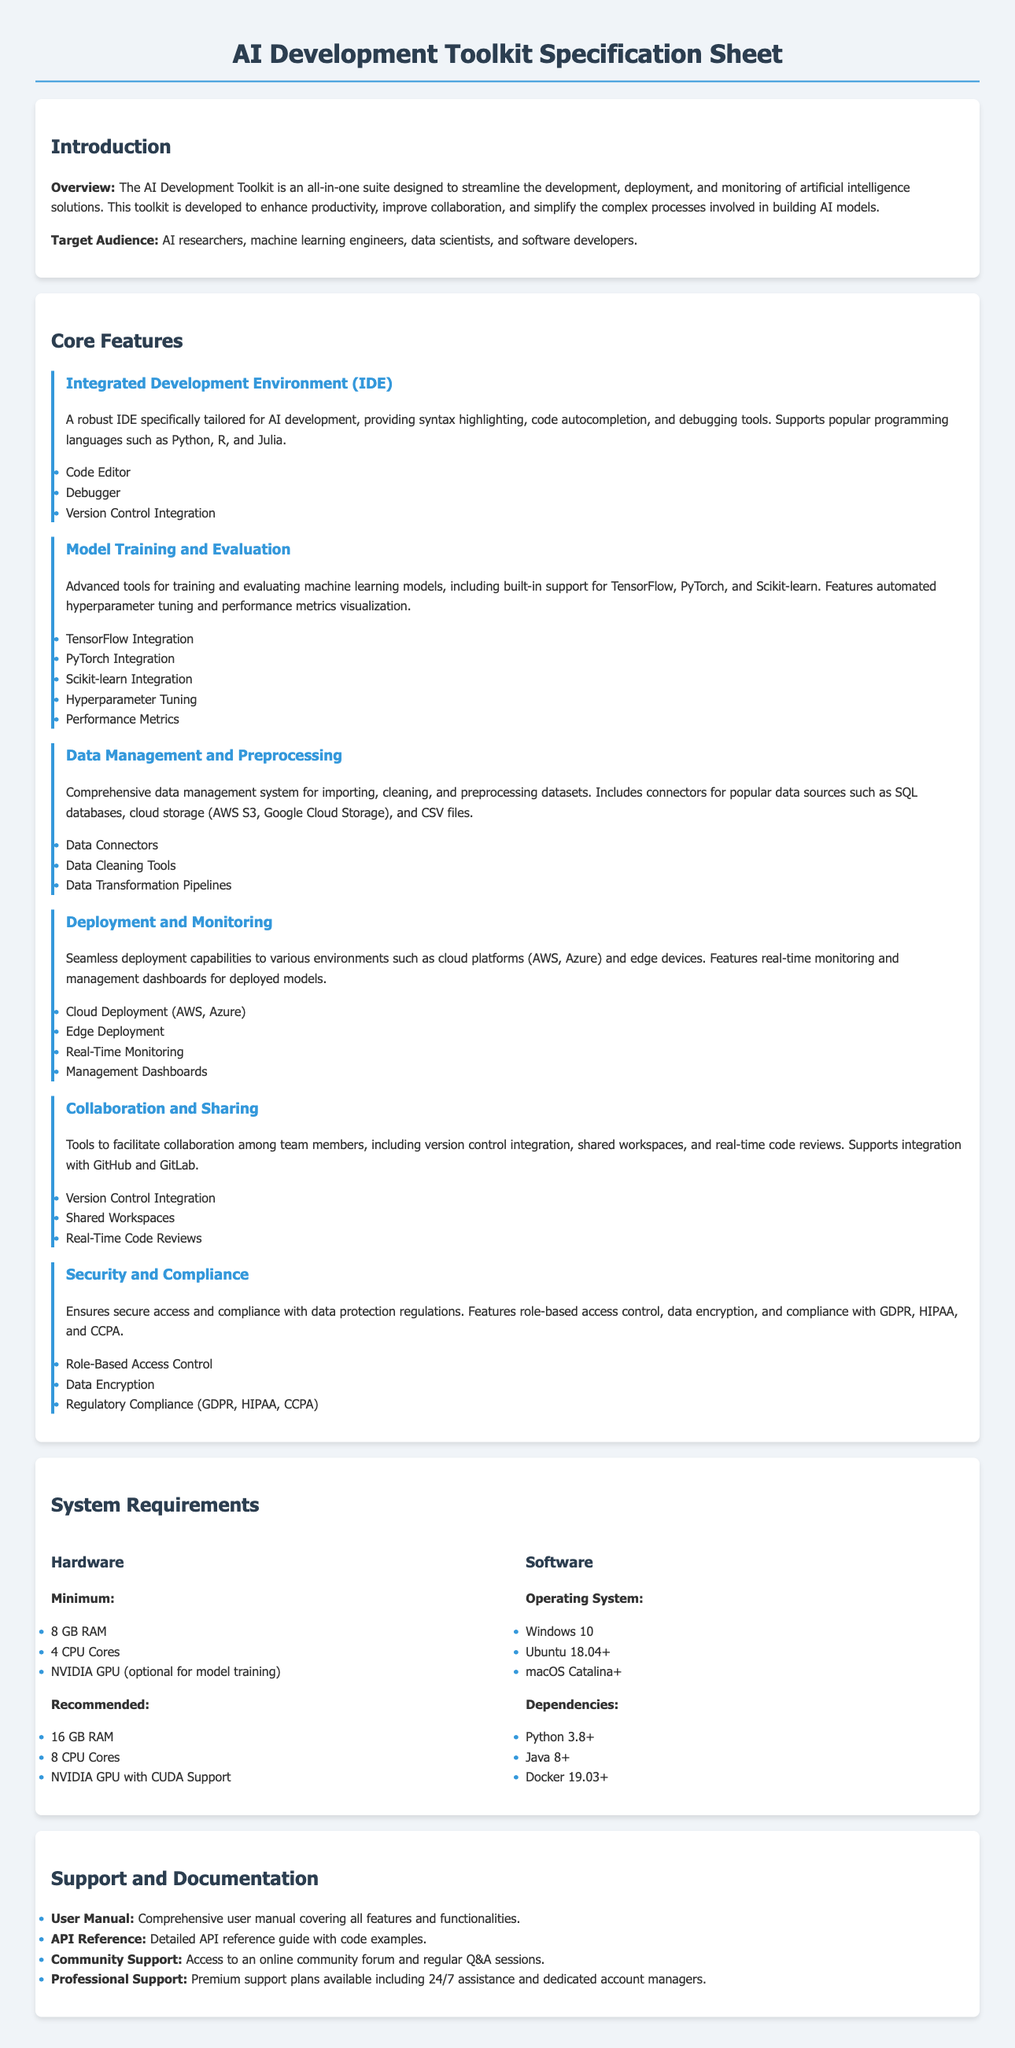What is the target audience for the toolkit? The target audience is specified as AI researchers, machine learning engineers, data scientists, and software developers.
Answer: AI researchers, machine learning engineers, data scientists, software developers How many core features are listed in the document? The document lists a total of six core features under the Core Features section.
Answer: Six What are the recommended software dependencies? The recommended software dependencies can be found under the Software section, which includes Python, Java, and Docker versions.
Answer: Python 3.8+, Java 8+, Docker 19.03+ What type of deployment capabilities does the toolkit provide? The toolkit provides deployment capabilities to cloud platforms and edge devices, as mentioned in the Deployment and Monitoring section.
Answer: Cloud platforms, edge devices Which compliance standards does the toolkit adhere to? The compliance standards referenced in the Security and Compliance section include GDPR, HIPAA, and CCPA.
Answer: GDPR, HIPAA, CCPA What is the minimum RAM requirement for the toolkit? The minimum RAM requirement is stated under Hardware in the System Requirements section.
Answer: 8 GB RAM What feature supports automated hyperparameter tuning? The feature that supports automated hyperparameter tuning is specified in the Model Training and Evaluation core features section.
Answer: Model Training and Evaluation Does the toolkit include a user manual? The Support and Documentation section mentions the availability of a comprehensive user manual covering all features.
Answer: Yes 